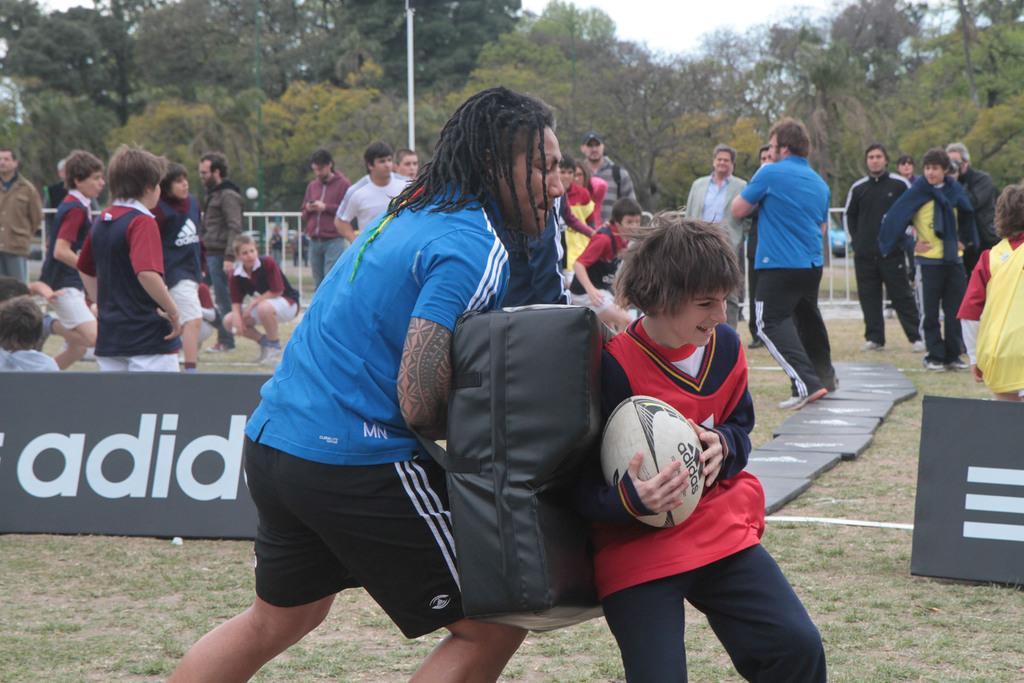Could you give a brief overview of what you see in this image? This boy is holding a ball. Most of the persons are standing. This person is in a squat position. Far there are number of trees. 